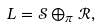<formula> <loc_0><loc_0><loc_500><loc_500>L = \mathcal { S } \oplus _ { \pi } \mathcal { R } ,</formula> 